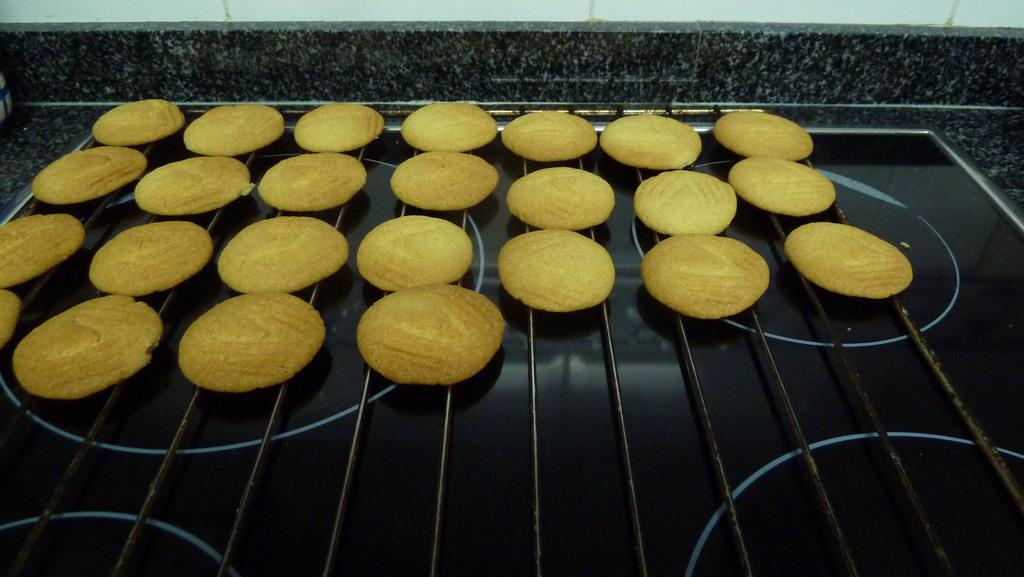What type of food can be seen in the image? There are biscuits in the image. How are the biscuits arranged in the image? The biscuits are placed on a grill. What color are the biscuits in the image? The biscuits are yellow in color. What color is the grill on which the biscuits are placed? The grill is black in color. What can be seen in the background of the image? There is a wall visible in the background of the image. How much profit can be made from the biscuits in the image? There is no information about profit in the image, as it only shows biscuits placed on a grill. 